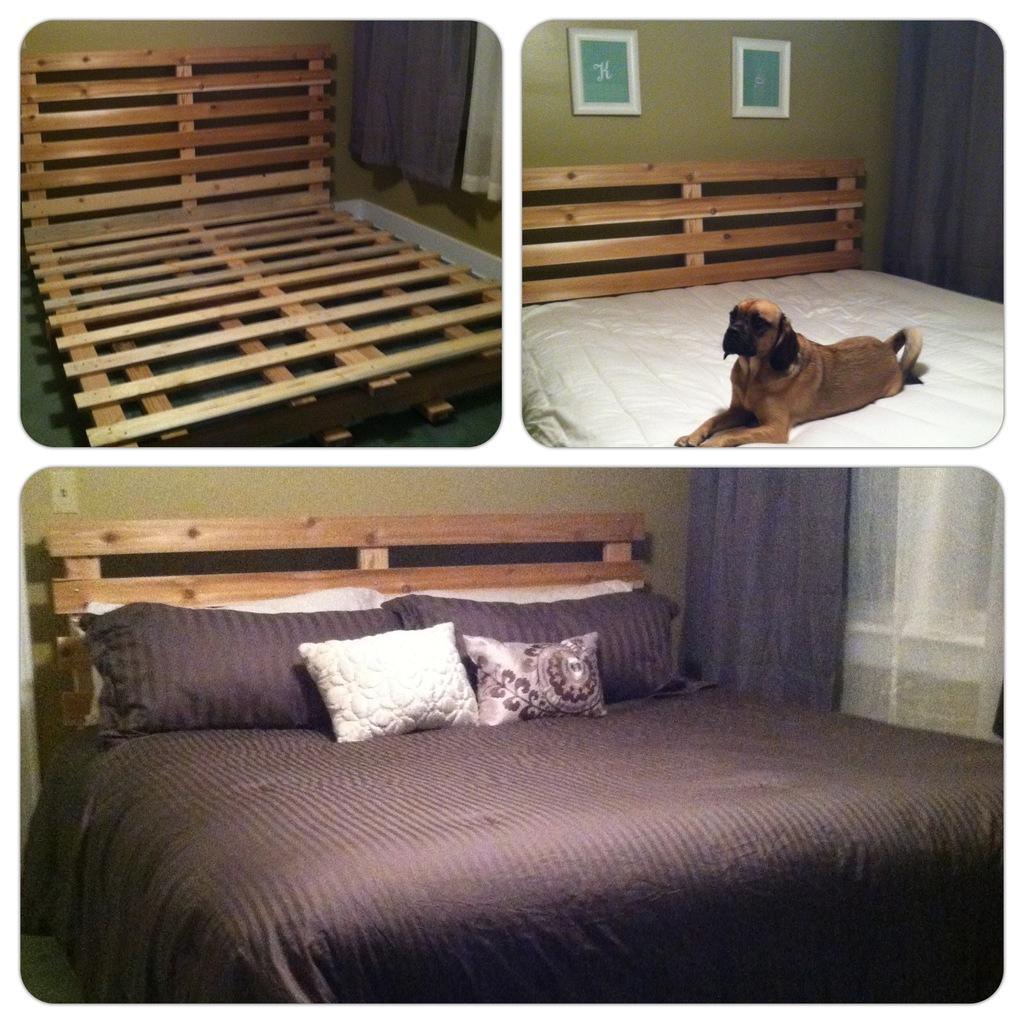Could you give a brief overview of what you see in this image? In this image we can see a wooden bed, dog sitting on bed and bed with bed sheet and pillows. 